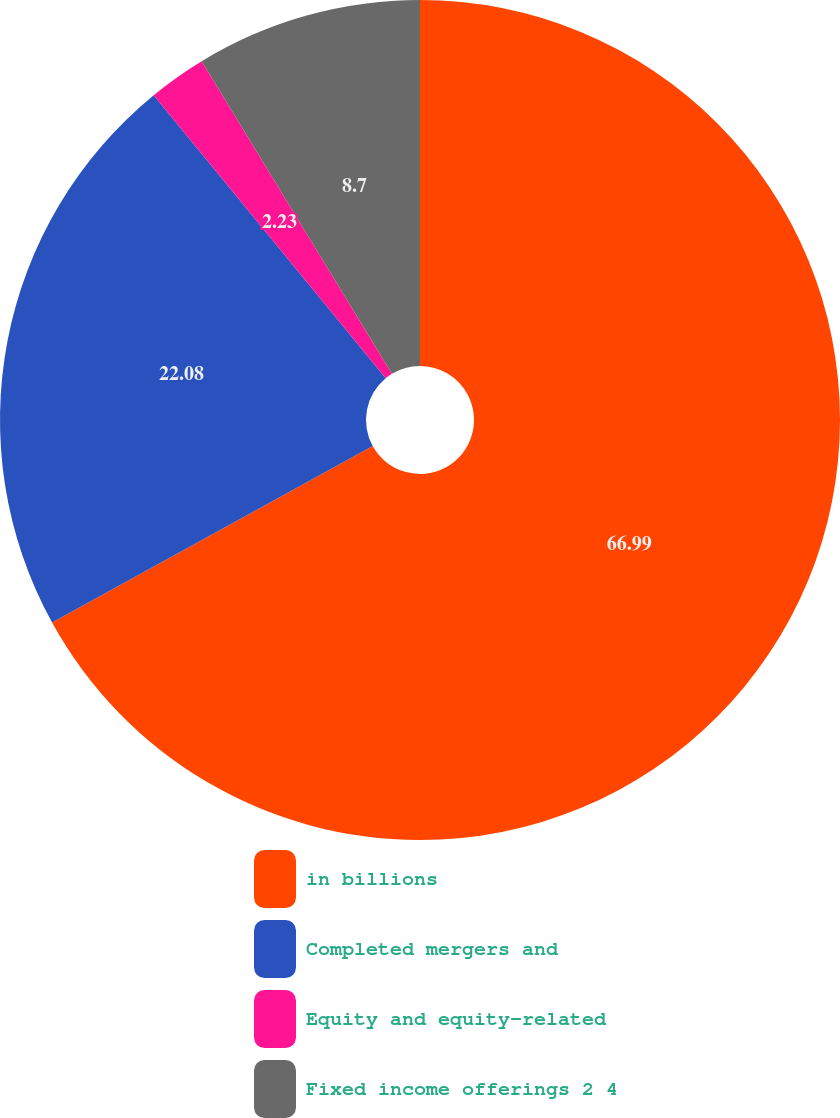<chart> <loc_0><loc_0><loc_500><loc_500><pie_chart><fcel>in billions<fcel>Completed mergers and<fcel>Equity and equity-related<fcel>Fixed income offerings 2 4<nl><fcel>66.99%<fcel>22.08%<fcel>2.23%<fcel>8.7%<nl></chart> 